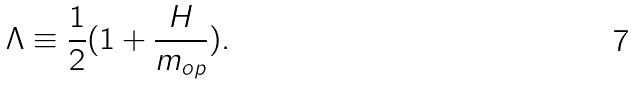<formula> <loc_0><loc_0><loc_500><loc_500>\Lambda \equiv \frac { 1 } { 2 } ( 1 + \frac { H } { m _ { o p } } ) .</formula> 